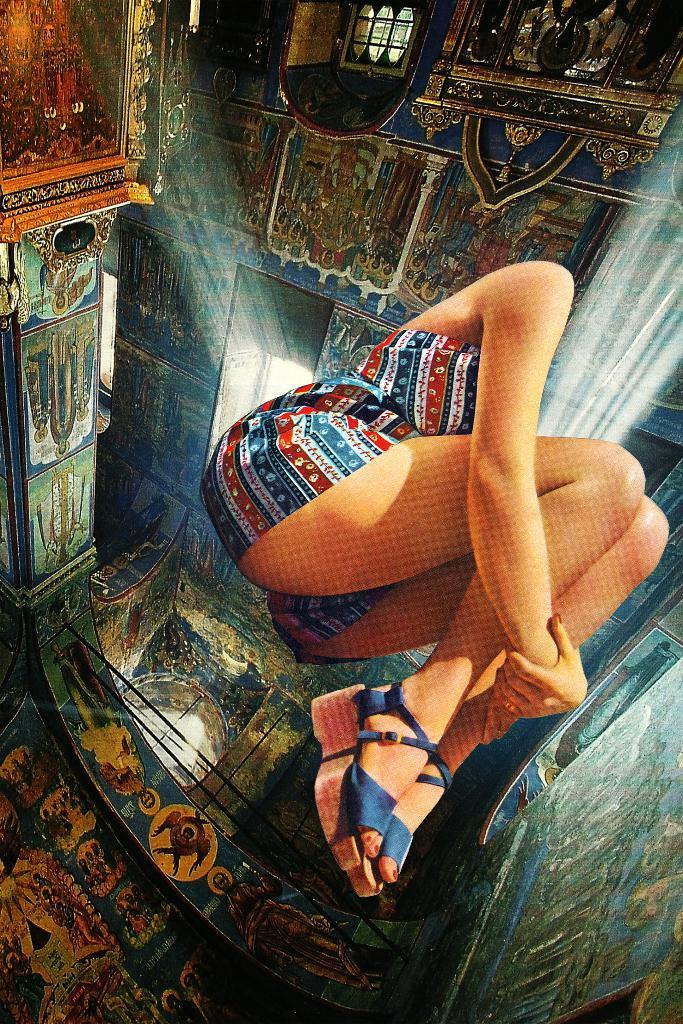What is located in the foreground of the image? There is a person in the foreground of the image. What can be seen in the background of the image? There is a wall, sculptures, windows, and a fence in the background of the image. Can you describe the setting of the image? The image may have been taken in a building, as indicated by the presence of a wall and windows. What type of ant can be seen crawling on the person in the image? There are no ants present in the image; the focus is on the person and the background elements. 